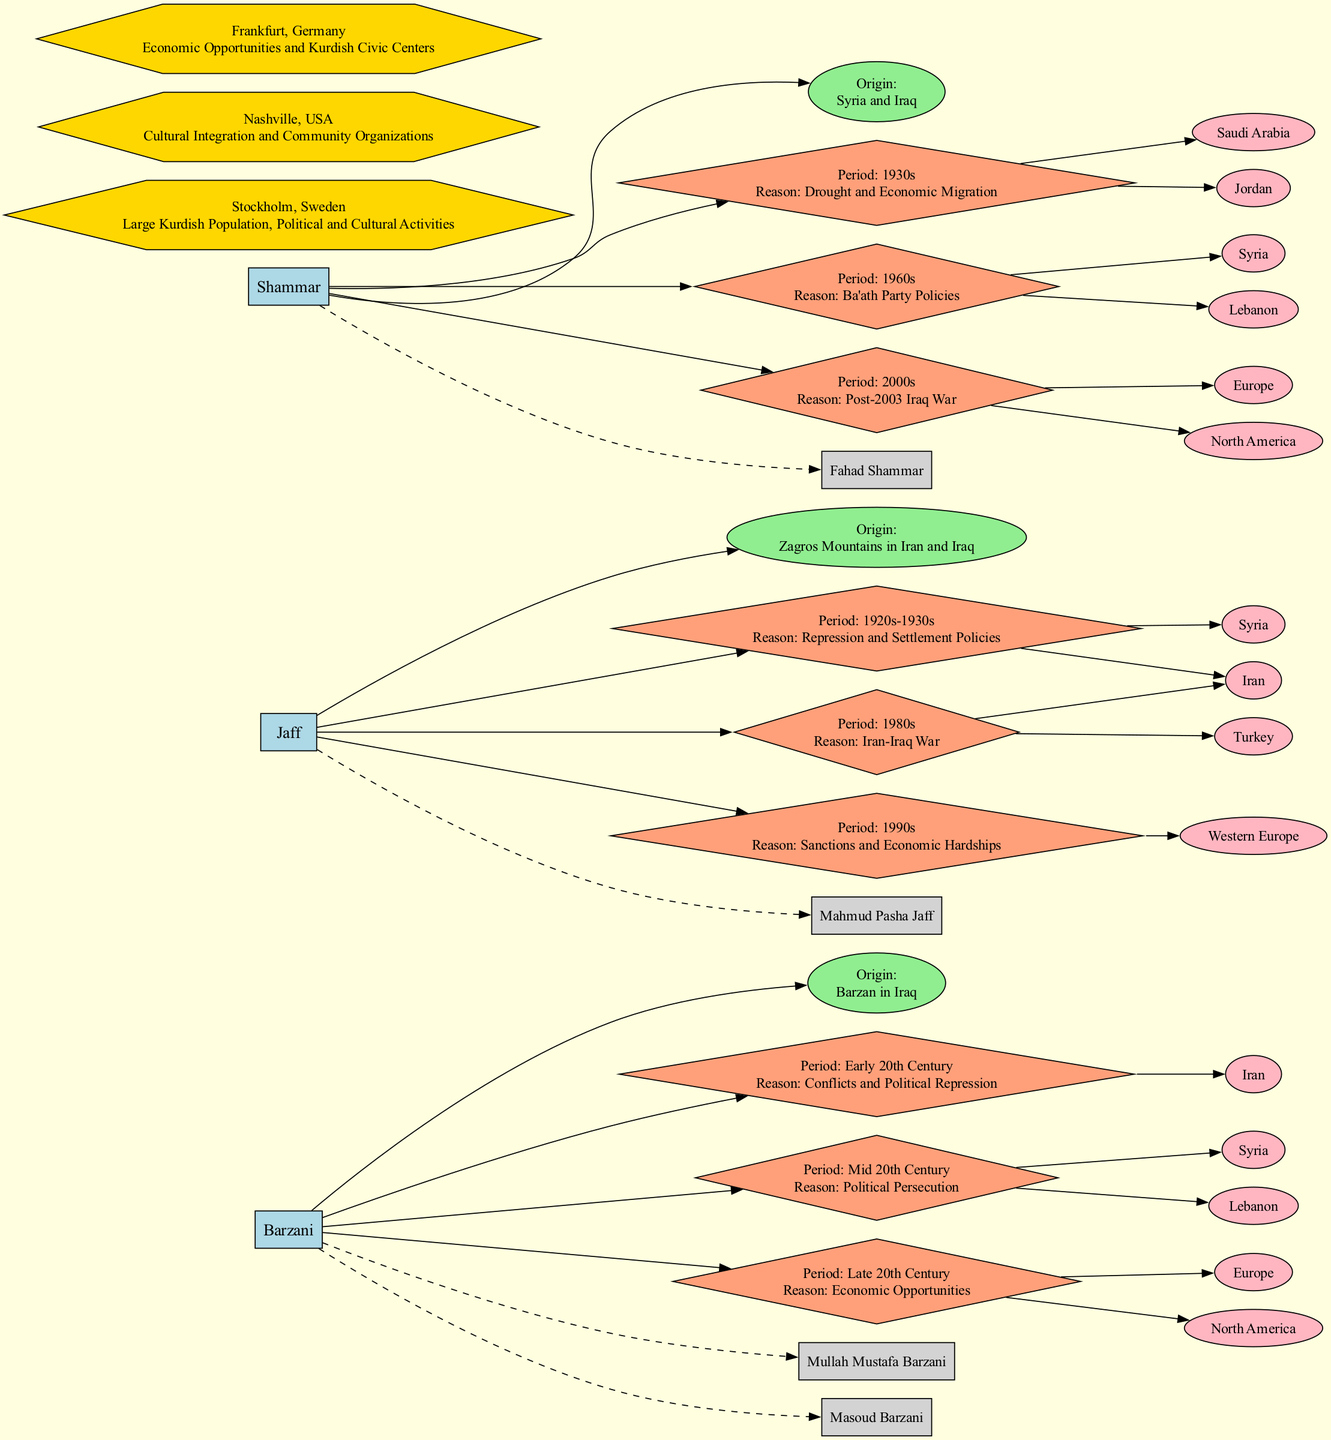What is the origin region of the Barzani tribe? The diagram shows that the Barzani tribe's origin region is Barzan in Iraq. This information is represented by the node connected to the Barzani tribe.
Answer: Barzan in Iraq How many notable figures are associated with the Jaff tribe? The Jaff tribe node lists one notable figure: Mahmud Pasha Jaff. Since there is only one figure mentioned, the count is one.
Answer: 1 What was the migration reason for the Shammar tribe in the 1960s? The diagram indicates that the migration reason for the Shammar tribe in the 1960s was Ba'ath Party Policies. This is shown in the appropriate migration path node.
Answer: Ba'ath Party Policies Which destinations did the Barzani tribe migrate to in the Late 20th Century? According to the migration paths shown in the diagram, the Barzani tribe migrated to Europe and North America in the Late 20th Century. These destinations are listed under that particular migration period.
Answer: Europe, North America What is a common migration destination for the Jaff tribe in the 1990s? The diagram shows that the Jaff tribe migrated primarily to Western Europe in the 1990s due to sanctions and economic hardships. This information is found under the respective migration path node.
Answer: Western Europe Which tribe has notable figures including Mullah Mustafa Barzani? The diagram indicates that Mullah Mustafa Barzani is a notable figure associated with the Barzani tribe. This information is linked by a dashed edge from the tribe node to the figure node.
Answer: Barzani How many migration paths are listed for the Shammar tribe? The diagram outlines three distinct migration paths for the Shammar tribe: one in the 1930s, one in the 1960s, and one in the 2000s. This count can be derived by counting the migration path nodes connected to the Shammar tribe.
Answer: 3 In which country is the diaspora center located that focuses on cultural integration? The diaspora center located in Nashville, USA, focuses on cultural integration and community organizations, as indicated in the center node in the diagram.
Answer: USA Which tribe migrated due to conflicts and political repression in the Early 20th Century? The diagram states that the Barzani tribe faced conflicts and political repression prompting migration to Iran in the Early 20th Century. This information is reflected in the migration path information.
Answer: Barzani 